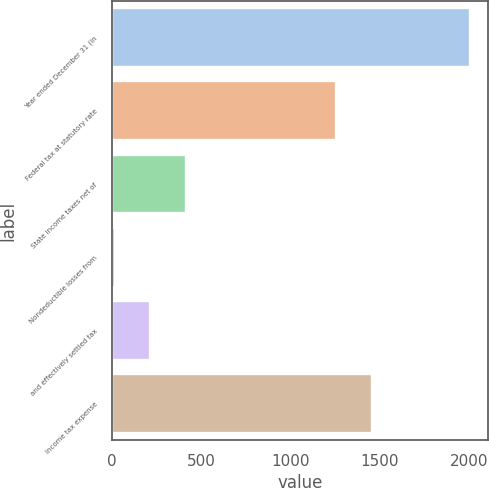Convert chart. <chart><loc_0><loc_0><loc_500><loc_500><bar_chart><fcel>Year ended December 31 (in<fcel>Federal tax at statutory rate<fcel>State income taxes net of<fcel>Nondeductible losses from<fcel>and effectively settled tax<fcel>Income tax expense<nl><fcel>2006<fcel>1258<fcel>415.6<fcel>18<fcel>216.8<fcel>1456.8<nl></chart> 